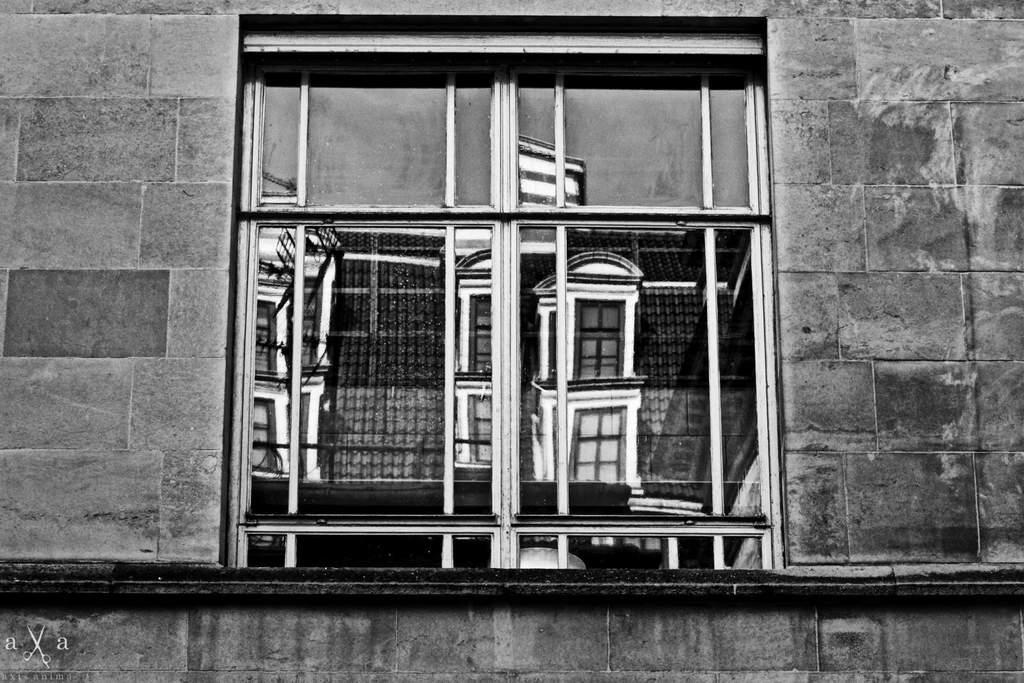What is the main subject of the image? The main subject of the image is a window of a building. Are there any additional features on the left side of the image? Yes, there is a watermark on the left side of the image. What else can be seen in the image besides the window and watermark? There is a wall visible in the image. How would you describe the color scheme of the image? The image is black and white. Can you see a scarecrow standing near the building in the image? No, there is no scarecrow present in the image. How many bees are buzzing around the watermark in the image? There are no bees visible in the image. 